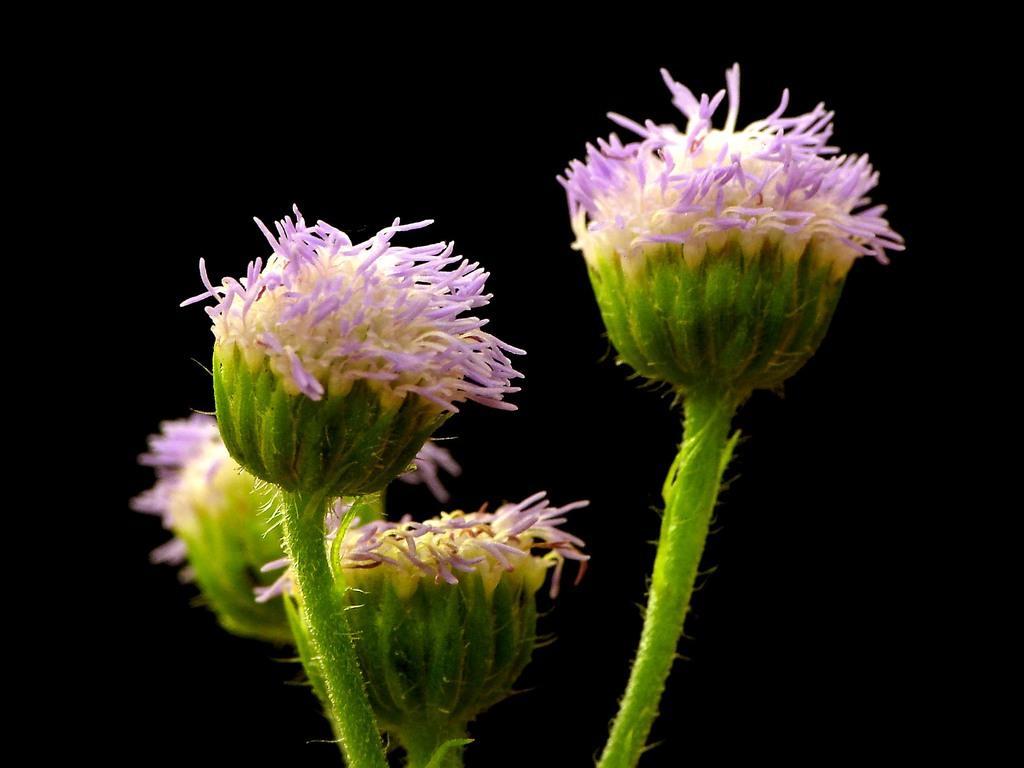How would you summarize this image in a sentence or two? There are some white and violet color flowers with stem. In the background it is dark. 